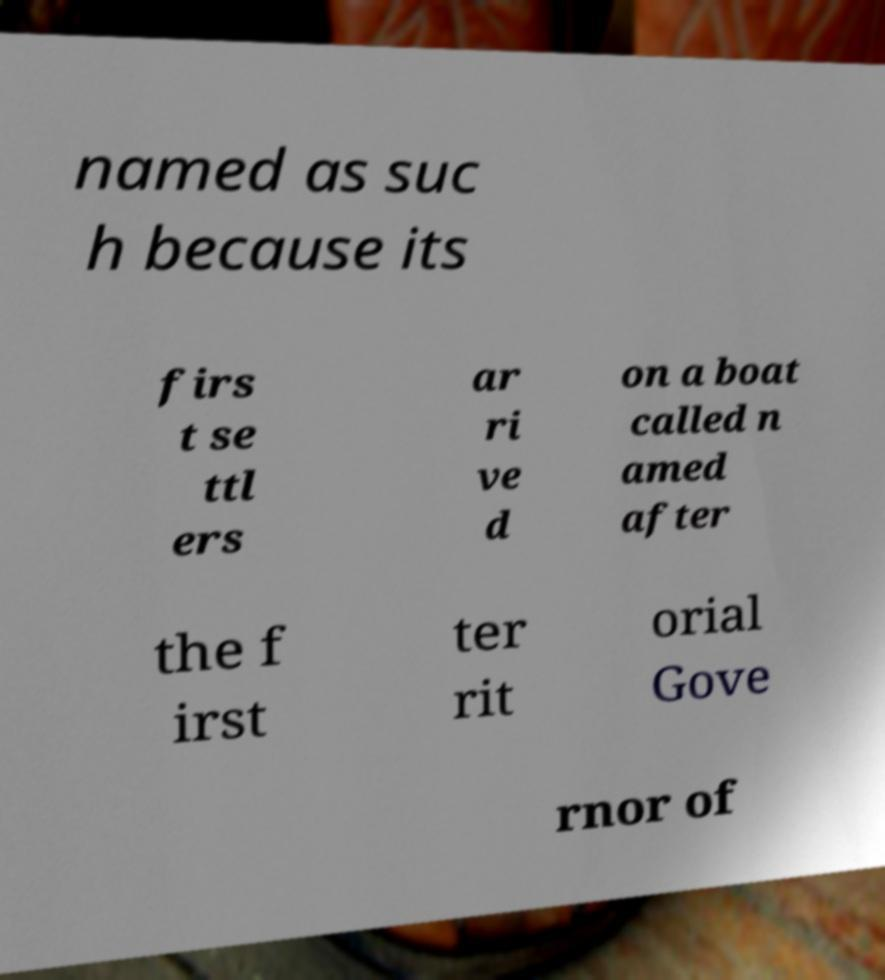What messages or text are displayed in this image? I need them in a readable, typed format. named as suc h because its firs t se ttl ers ar ri ve d on a boat called n amed after the f irst ter rit orial Gove rnor of 